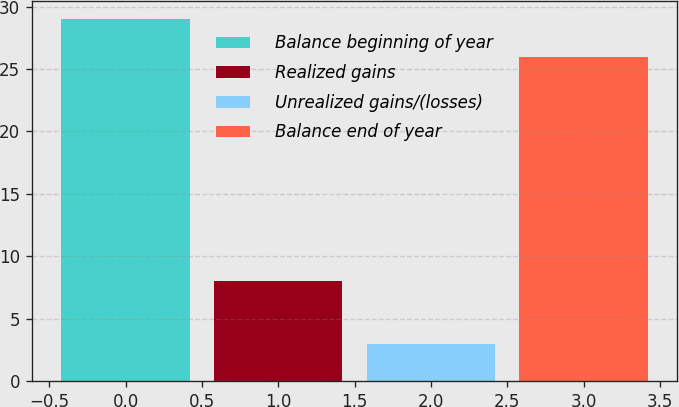Convert chart to OTSL. <chart><loc_0><loc_0><loc_500><loc_500><bar_chart><fcel>Balance beginning of year<fcel>Realized gains<fcel>Unrealized gains/(losses)<fcel>Balance end of year<nl><fcel>29<fcel>8<fcel>3<fcel>26<nl></chart> 